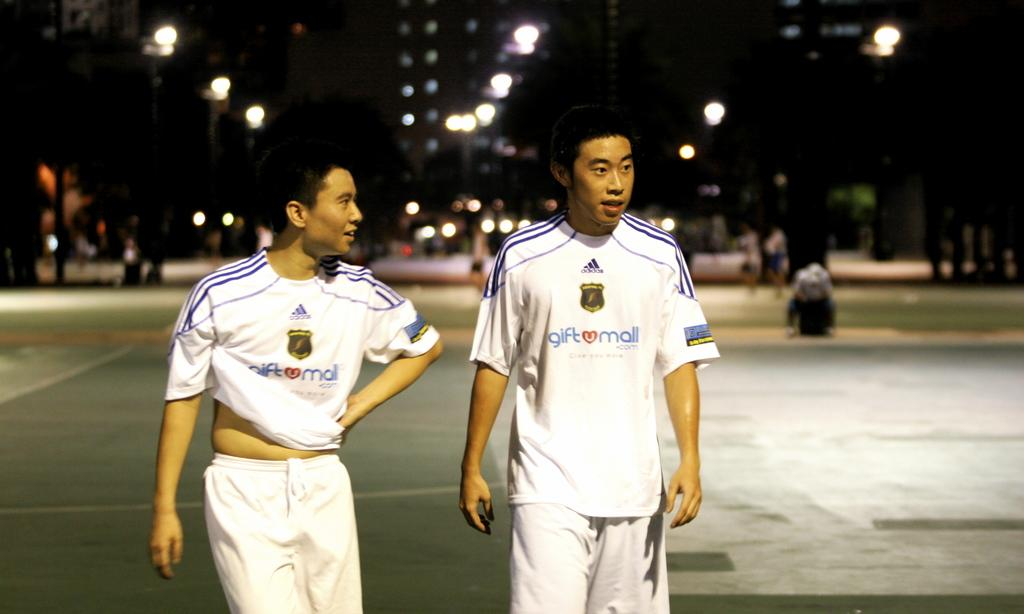Provide a one-sentence caption for the provided image. Two men walking together at night in white uniforms that say giftumall.com on the front. 